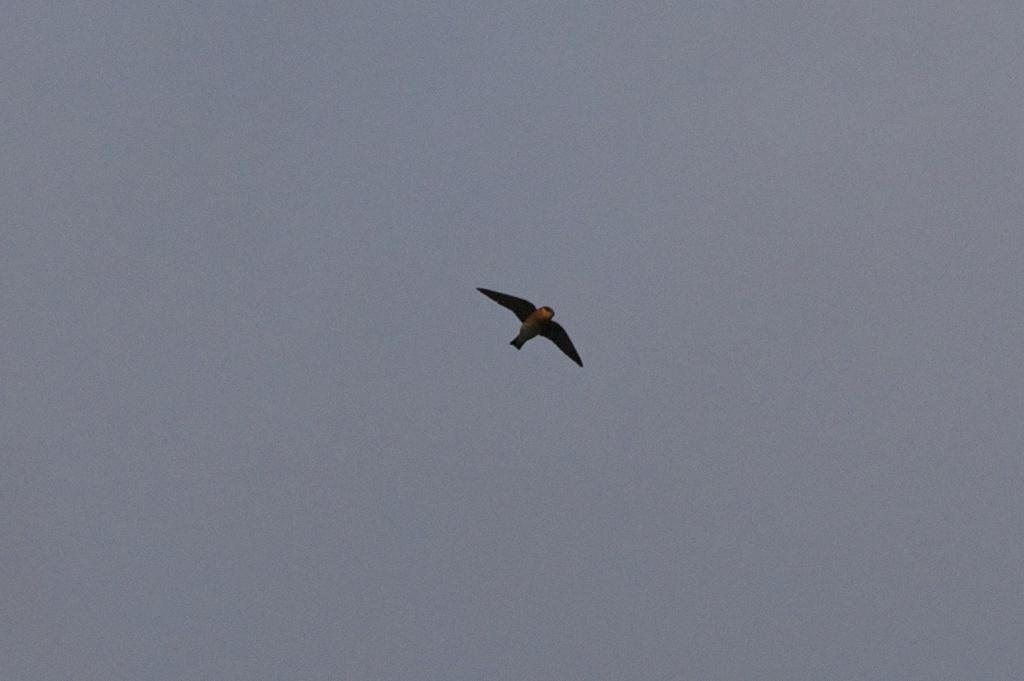What is the main subject in the foreground of the image? There is a bird in the foreground of the image. What is the bird doing in the image? The bird is in the air. What can be seen in the background of the image? The sky is visible in the background of the image. What arithmetic problem is the bird solving in the image? There is no arithmetic problem present in the image; it features a bird flying in the air. Can you describe the bedroom in the image? There is no bedroom present in the image; it features a bird flying in the air with the sky as the background. 